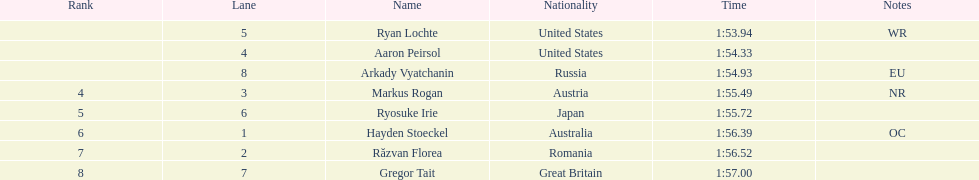How many names are listed? 8. 